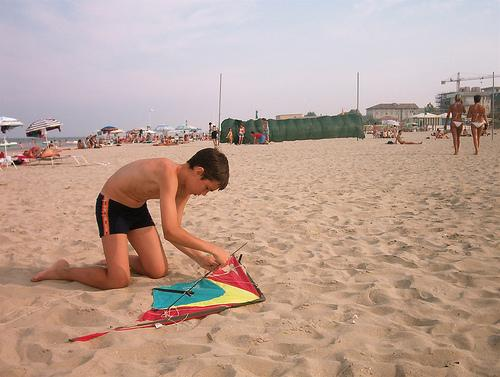Where does he hope his toy will go?

Choices:
A) sky
B) trees
C) water
D) sand sky 